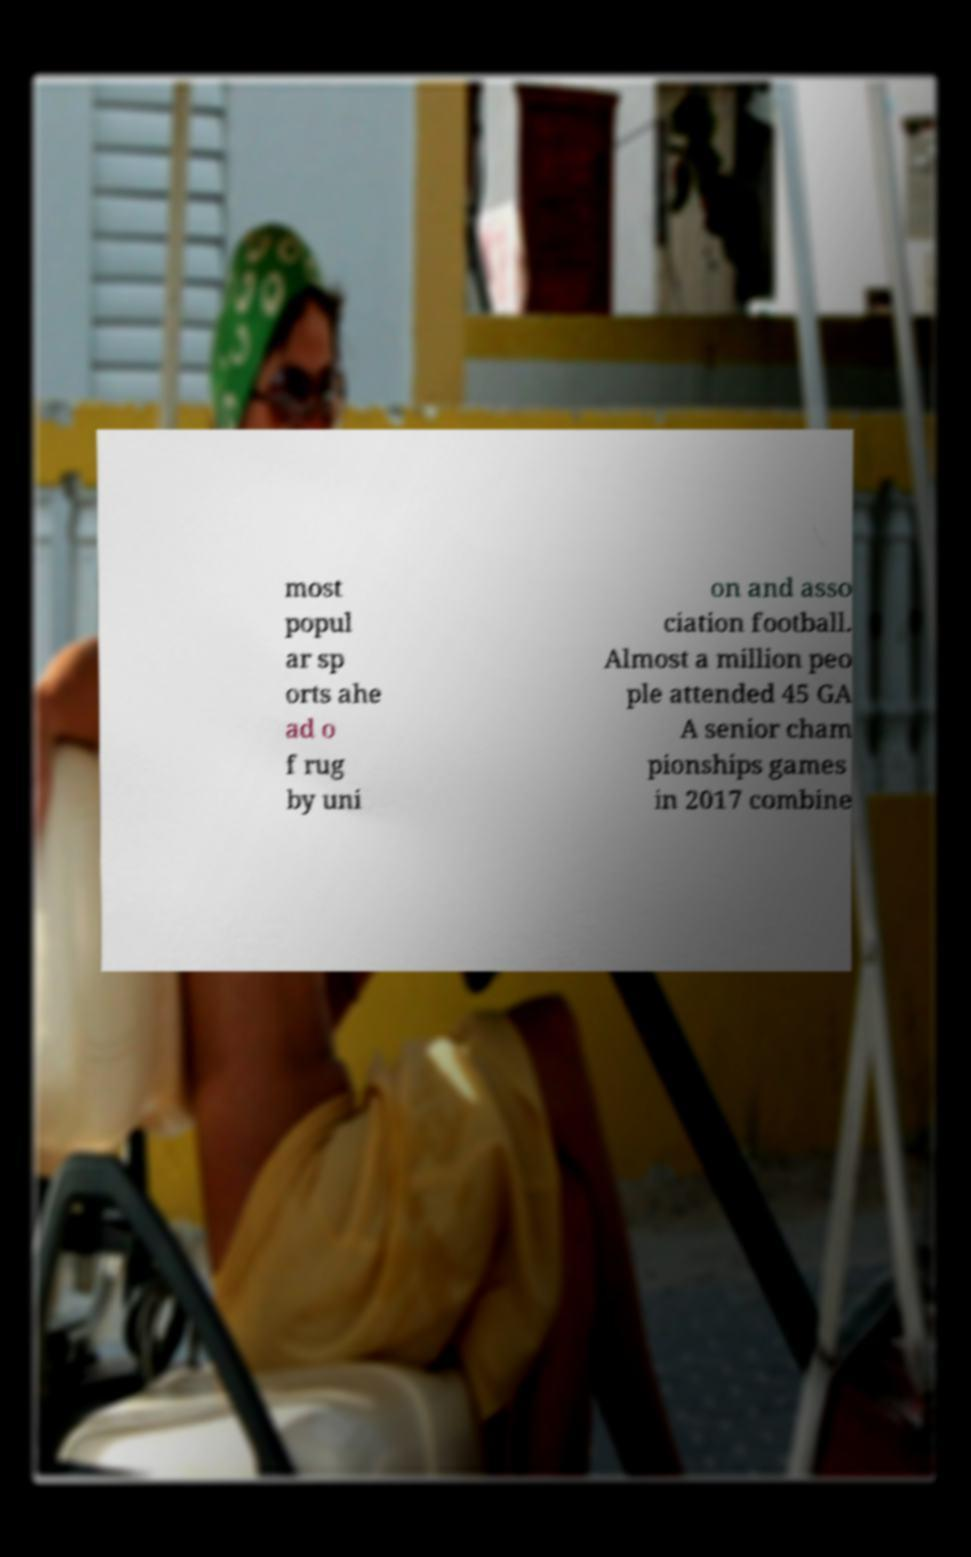Can you read and provide the text displayed in the image?This photo seems to have some interesting text. Can you extract and type it out for me? most popul ar sp orts ahe ad o f rug by uni on and asso ciation football. Almost a million peo ple attended 45 GA A senior cham pionships games in 2017 combine 